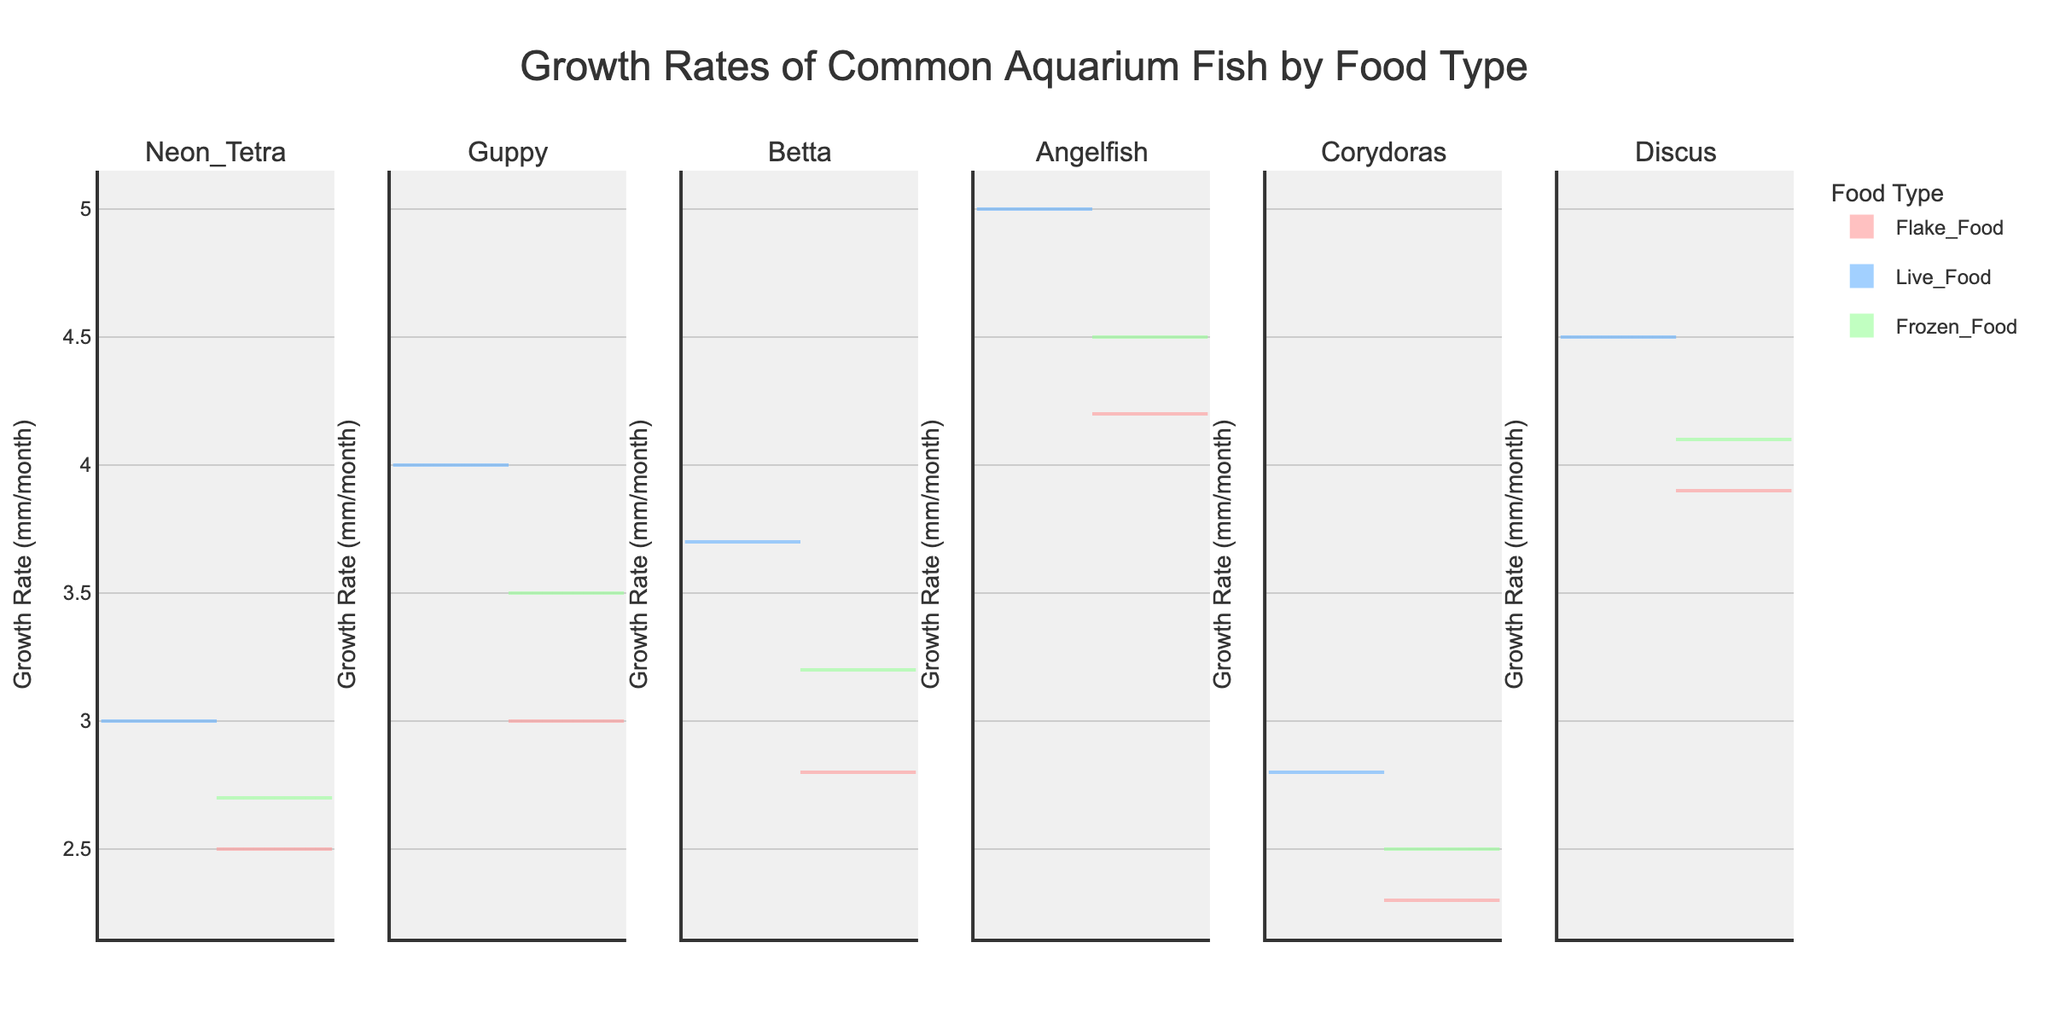What's the title of the figure? The title of the figure is displayed at the top center and is 'Growth Rates of Common Aquarium Fish by Food Type'.
Answer: Growth Rates of Common Aquarium Fish by Food Type How are the growth rates distributed for Guppies fed with Live Food? The area for Live Food on the violin chart for Guppies extends both positively and negatively with the densest area around the 3-4 mm/month mark.
Answer: 3-4 mm/month Which fish species shows the highest mean growth rate with Live Food? The mean line in the Live Food section for Angelfish appears higher than other fish species.
Answer: Angelfish What is the average growth rate for Discus fed with Flake Food and Frozen Food? From the graph, the average growth rate for Flake Food is around 3.9 mm/month and for Frozen Food is around 4.1 mm/month, their sum is 8, divided by 2 is 4.
Answer: 4 mm/month Which fish species have the growth rate greater with Frozen Food than with Flake Food? By comparing the mean lines in the Frozen Food and Flake Food sections, Guppy, Betta, Angelfish, and Discus have higher growth rates with Frozen Food.
Answer: Guppy, Betta, Angelfish, Discus What is the growth rate range for Betta fed with Live Food? The violin plot for Live Food for Betta extends from around 3.0 mm/month to approximately 4.0 mm/month, so their range is 1.0.
Answer: 1.0 mm/month Which food type shows the widest growth rate distribution for Neon Tetra? For Neon Tetra, the violin plot for Live Food has a wider distribution than Flake Food or Frozen Food.
Answer: Live Food Is the growth rate for Angelfish higher with Flake Food or Live Food? By comparing the mean lines in the Flake Food and Live Food sections for Angelfish, the mean with Live Food is higher.
Answer: Live Food What is the range of growth rates for Corydoras fed with Frozen Food? The Frozen Food section for Corydoras shows a range from around 2.2 mm/month to approximately 2.7 mm/month, so their range is 0.5.
Answer: 0.5 mm/month 